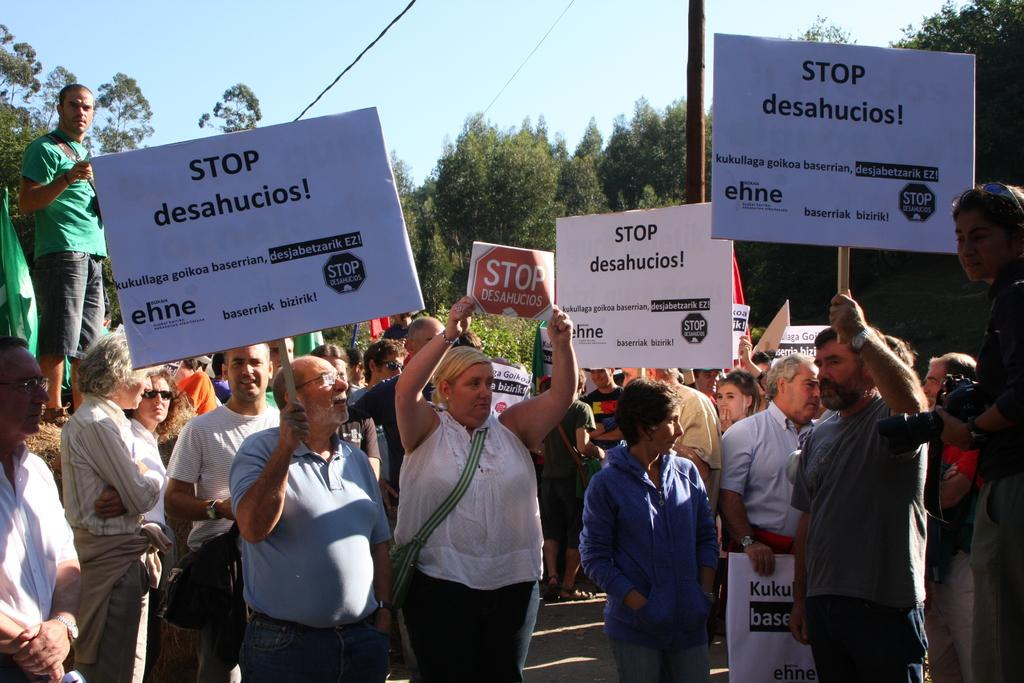What are the people in the image doing? The people in the image are standing on the road and holding picket cards. What can be seen in the background of the image? There are trees, a pole with wires, and the sky visible in the background of the image. What type of canvas is being used to display the flesh in the image? There is no canvas or flesh present in the image; it features people holding picket cards on a road. Is there a bomb visible in the image? No, there is no bomb present in the image. 